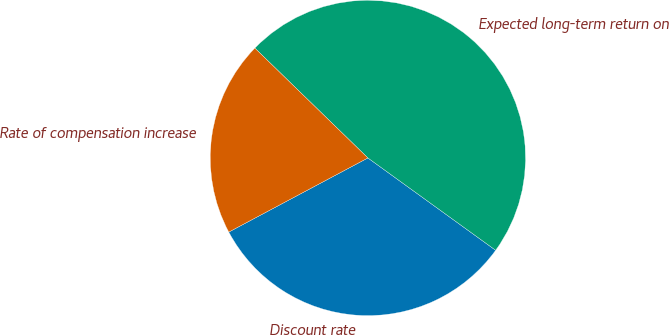Convert chart. <chart><loc_0><loc_0><loc_500><loc_500><pie_chart><fcel>Discount rate<fcel>Expected long-term return on<fcel>Rate of compensation increase<nl><fcel>32.25%<fcel>47.69%<fcel>20.06%<nl></chart> 